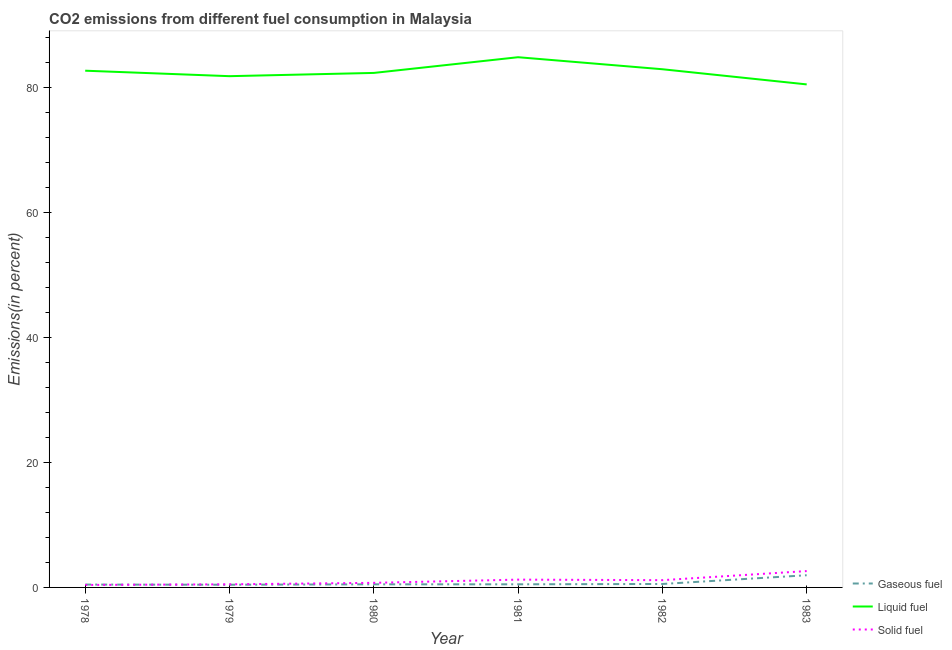How many different coloured lines are there?
Offer a very short reply. 3. Is the number of lines equal to the number of legend labels?
Offer a terse response. Yes. What is the percentage of solid fuel emission in 1982?
Make the answer very short. 1.16. Across all years, what is the maximum percentage of liquid fuel emission?
Your answer should be compact. 84.83. Across all years, what is the minimum percentage of gaseous fuel emission?
Offer a very short reply. 0.43. In which year was the percentage of gaseous fuel emission minimum?
Provide a short and direct response. 1979. What is the total percentage of gaseous fuel emission in the graph?
Your answer should be very brief. 4.39. What is the difference between the percentage of gaseous fuel emission in 1981 and that in 1982?
Keep it short and to the point. -0.05. What is the difference between the percentage of solid fuel emission in 1979 and the percentage of liquid fuel emission in 1978?
Your answer should be very brief. -82.18. What is the average percentage of liquid fuel emission per year?
Make the answer very short. 82.5. In the year 1978, what is the difference between the percentage of liquid fuel emission and percentage of solid fuel emission?
Your answer should be very brief. 82.28. What is the ratio of the percentage of gaseous fuel emission in 1978 to that in 1983?
Provide a short and direct response. 0.23. Is the percentage of liquid fuel emission in 1982 less than that in 1983?
Provide a succinct answer. No. What is the difference between the highest and the second highest percentage of solid fuel emission?
Make the answer very short. 1.37. What is the difference between the highest and the lowest percentage of solid fuel emission?
Give a very brief answer. 2.22. Is it the case that in every year, the sum of the percentage of gaseous fuel emission and percentage of liquid fuel emission is greater than the percentage of solid fuel emission?
Ensure brevity in your answer.  Yes. Is the percentage of liquid fuel emission strictly greater than the percentage of gaseous fuel emission over the years?
Keep it short and to the point. Yes. How many years are there in the graph?
Your response must be concise. 6. Are the values on the major ticks of Y-axis written in scientific E-notation?
Keep it short and to the point. No. Does the graph contain any zero values?
Offer a very short reply. No. How many legend labels are there?
Your answer should be very brief. 3. What is the title of the graph?
Your response must be concise. CO2 emissions from different fuel consumption in Malaysia. What is the label or title of the Y-axis?
Make the answer very short. Emissions(in percent). What is the Emissions(in percent) in Gaseous fuel in 1978?
Offer a terse response. 0.46. What is the Emissions(in percent) of Liquid fuel in 1978?
Your response must be concise. 82.67. What is the Emissions(in percent) of Solid fuel in 1978?
Your answer should be compact. 0.39. What is the Emissions(in percent) in Gaseous fuel in 1979?
Provide a short and direct response. 0.43. What is the Emissions(in percent) in Liquid fuel in 1979?
Offer a very short reply. 81.8. What is the Emissions(in percent) in Solid fuel in 1979?
Your response must be concise. 0.5. What is the Emissions(in percent) in Gaseous fuel in 1980?
Provide a short and direct response. 0.5. What is the Emissions(in percent) of Liquid fuel in 1980?
Give a very brief answer. 82.32. What is the Emissions(in percent) in Solid fuel in 1980?
Provide a succinct answer. 0.73. What is the Emissions(in percent) in Gaseous fuel in 1981?
Keep it short and to the point. 0.5. What is the Emissions(in percent) of Liquid fuel in 1981?
Your answer should be very brief. 84.83. What is the Emissions(in percent) of Solid fuel in 1981?
Ensure brevity in your answer.  1.25. What is the Emissions(in percent) in Gaseous fuel in 1982?
Provide a short and direct response. 0.55. What is the Emissions(in percent) of Liquid fuel in 1982?
Provide a short and direct response. 82.91. What is the Emissions(in percent) in Solid fuel in 1982?
Ensure brevity in your answer.  1.16. What is the Emissions(in percent) in Gaseous fuel in 1983?
Offer a very short reply. 1.95. What is the Emissions(in percent) of Liquid fuel in 1983?
Keep it short and to the point. 80.48. What is the Emissions(in percent) in Solid fuel in 1983?
Provide a succinct answer. 2.62. Across all years, what is the maximum Emissions(in percent) in Gaseous fuel?
Offer a very short reply. 1.95. Across all years, what is the maximum Emissions(in percent) of Liquid fuel?
Provide a succinct answer. 84.83. Across all years, what is the maximum Emissions(in percent) of Solid fuel?
Ensure brevity in your answer.  2.62. Across all years, what is the minimum Emissions(in percent) of Gaseous fuel?
Offer a very short reply. 0.43. Across all years, what is the minimum Emissions(in percent) of Liquid fuel?
Your response must be concise. 80.48. Across all years, what is the minimum Emissions(in percent) of Solid fuel?
Make the answer very short. 0.39. What is the total Emissions(in percent) in Gaseous fuel in the graph?
Ensure brevity in your answer.  4.39. What is the total Emissions(in percent) of Liquid fuel in the graph?
Make the answer very short. 495.01. What is the total Emissions(in percent) in Solid fuel in the graph?
Provide a succinct answer. 6.66. What is the difference between the Emissions(in percent) of Gaseous fuel in 1978 and that in 1979?
Offer a terse response. 0.03. What is the difference between the Emissions(in percent) in Liquid fuel in 1978 and that in 1979?
Offer a very short reply. 0.87. What is the difference between the Emissions(in percent) in Solid fuel in 1978 and that in 1979?
Provide a short and direct response. -0.1. What is the difference between the Emissions(in percent) in Gaseous fuel in 1978 and that in 1980?
Your response must be concise. -0.04. What is the difference between the Emissions(in percent) in Liquid fuel in 1978 and that in 1980?
Offer a terse response. 0.35. What is the difference between the Emissions(in percent) in Solid fuel in 1978 and that in 1980?
Make the answer very short. -0.34. What is the difference between the Emissions(in percent) of Gaseous fuel in 1978 and that in 1981?
Your response must be concise. -0.04. What is the difference between the Emissions(in percent) in Liquid fuel in 1978 and that in 1981?
Provide a short and direct response. -2.16. What is the difference between the Emissions(in percent) in Solid fuel in 1978 and that in 1981?
Your response must be concise. -0.85. What is the difference between the Emissions(in percent) of Gaseous fuel in 1978 and that in 1982?
Make the answer very short. -0.09. What is the difference between the Emissions(in percent) in Liquid fuel in 1978 and that in 1982?
Give a very brief answer. -0.23. What is the difference between the Emissions(in percent) in Solid fuel in 1978 and that in 1982?
Keep it short and to the point. -0.77. What is the difference between the Emissions(in percent) of Gaseous fuel in 1978 and that in 1983?
Make the answer very short. -1.49. What is the difference between the Emissions(in percent) of Liquid fuel in 1978 and that in 1983?
Your answer should be very brief. 2.19. What is the difference between the Emissions(in percent) of Solid fuel in 1978 and that in 1983?
Ensure brevity in your answer.  -2.22. What is the difference between the Emissions(in percent) in Gaseous fuel in 1979 and that in 1980?
Offer a very short reply. -0.07. What is the difference between the Emissions(in percent) of Liquid fuel in 1979 and that in 1980?
Your response must be concise. -0.52. What is the difference between the Emissions(in percent) of Solid fuel in 1979 and that in 1980?
Ensure brevity in your answer.  -0.24. What is the difference between the Emissions(in percent) of Gaseous fuel in 1979 and that in 1981?
Offer a very short reply. -0.07. What is the difference between the Emissions(in percent) in Liquid fuel in 1979 and that in 1981?
Provide a short and direct response. -3.03. What is the difference between the Emissions(in percent) of Solid fuel in 1979 and that in 1981?
Provide a succinct answer. -0.75. What is the difference between the Emissions(in percent) of Gaseous fuel in 1979 and that in 1982?
Keep it short and to the point. -0.12. What is the difference between the Emissions(in percent) in Liquid fuel in 1979 and that in 1982?
Offer a terse response. -1.11. What is the difference between the Emissions(in percent) of Solid fuel in 1979 and that in 1982?
Your response must be concise. -0.67. What is the difference between the Emissions(in percent) in Gaseous fuel in 1979 and that in 1983?
Provide a short and direct response. -1.52. What is the difference between the Emissions(in percent) of Liquid fuel in 1979 and that in 1983?
Give a very brief answer. 1.32. What is the difference between the Emissions(in percent) of Solid fuel in 1979 and that in 1983?
Offer a terse response. -2.12. What is the difference between the Emissions(in percent) in Gaseous fuel in 1980 and that in 1981?
Keep it short and to the point. -0. What is the difference between the Emissions(in percent) of Liquid fuel in 1980 and that in 1981?
Provide a succinct answer. -2.51. What is the difference between the Emissions(in percent) of Solid fuel in 1980 and that in 1981?
Ensure brevity in your answer.  -0.52. What is the difference between the Emissions(in percent) in Gaseous fuel in 1980 and that in 1982?
Your response must be concise. -0.05. What is the difference between the Emissions(in percent) of Liquid fuel in 1980 and that in 1982?
Provide a short and direct response. -0.59. What is the difference between the Emissions(in percent) of Solid fuel in 1980 and that in 1982?
Your response must be concise. -0.43. What is the difference between the Emissions(in percent) in Gaseous fuel in 1980 and that in 1983?
Offer a very short reply. -1.45. What is the difference between the Emissions(in percent) of Liquid fuel in 1980 and that in 1983?
Provide a short and direct response. 1.84. What is the difference between the Emissions(in percent) in Solid fuel in 1980 and that in 1983?
Keep it short and to the point. -1.88. What is the difference between the Emissions(in percent) of Gaseous fuel in 1981 and that in 1982?
Your answer should be compact. -0.05. What is the difference between the Emissions(in percent) in Liquid fuel in 1981 and that in 1982?
Give a very brief answer. 1.92. What is the difference between the Emissions(in percent) of Solid fuel in 1981 and that in 1982?
Make the answer very short. 0.09. What is the difference between the Emissions(in percent) in Gaseous fuel in 1981 and that in 1983?
Provide a short and direct response. -1.45. What is the difference between the Emissions(in percent) of Liquid fuel in 1981 and that in 1983?
Your response must be concise. 4.35. What is the difference between the Emissions(in percent) of Solid fuel in 1981 and that in 1983?
Provide a succinct answer. -1.37. What is the difference between the Emissions(in percent) in Gaseous fuel in 1982 and that in 1983?
Offer a very short reply. -1.4. What is the difference between the Emissions(in percent) in Liquid fuel in 1982 and that in 1983?
Give a very brief answer. 2.42. What is the difference between the Emissions(in percent) of Solid fuel in 1982 and that in 1983?
Provide a short and direct response. -1.45. What is the difference between the Emissions(in percent) in Gaseous fuel in 1978 and the Emissions(in percent) in Liquid fuel in 1979?
Give a very brief answer. -81.34. What is the difference between the Emissions(in percent) in Gaseous fuel in 1978 and the Emissions(in percent) in Solid fuel in 1979?
Your response must be concise. -0.04. What is the difference between the Emissions(in percent) of Liquid fuel in 1978 and the Emissions(in percent) of Solid fuel in 1979?
Make the answer very short. 82.18. What is the difference between the Emissions(in percent) of Gaseous fuel in 1978 and the Emissions(in percent) of Liquid fuel in 1980?
Keep it short and to the point. -81.86. What is the difference between the Emissions(in percent) in Gaseous fuel in 1978 and the Emissions(in percent) in Solid fuel in 1980?
Keep it short and to the point. -0.28. What is the difference between the Emissions(in percent) in Liquid fuel in 1978 and the Emissions(in percent) in Solid fuel in 1980?
Your answer should be very brief. 81.94. What is the difference between the Emissions(in percent) of Gaseous fuel in 1978 and the Emissions(in percent) of Liquid fuel in 1981?
Your response must be concise. -84.37. What is the difference between the Emissions(in percent) of Gaseous fuel in 1978 and the Emissions(in percent) of Solid fuel in 1981?
Your answer should be very brief. -0.79. What is the difference between the Emissions(in percent) in Liquid fuel in 1978 and the Emissions(in percent) in Solid fuel in 1981?
Provide a succinct answer. 81.42. What is the difference between the Emissions(in percent) of Gaseous fuel in 1978 and the Emissions(in percent) of Liquid fuel in 1982?
Your answer should be compact. -82.45. What is the difference between the Emissions(in percent) of Gaseous fuel in 1978 and the Emissions(in percent) of Solid fuel in 1982?
Ensure brevity in your answer.  -0.71. What is the difference between the Emissions(in percent) of Liquid fuel in 1978 and the Emissions(in percent) of Solid fuel in 1982?
Your answer should be very brief. 81.51. What is the difference between the Emissions(in percent) of Gaseous fuel in 1978 and the Emissions(in percent) of Liquid fuel in 1983?
Your answer should be very brief. -80.03. What is the difference between the Emissions(in percent) of Gaseous fuel in 1978 and the Emissions(in percent) of Solid fuel in 1983?
Ensure brevity in your answer.  -2.16. What is the difference between the Emissions(in percent) of Liquid fuel in 1978 and the Emissions(in percent) of Solid fuel in 1983?
Keep it short and to the point. 80.06. What is the difference between the Emissions(in percent) in Gaseous fuel in 1979 and the Emissions(in percent) in Liquid fuel in 1980?
Your answer should be compact. -81.89. What is the difference between the Emissions(in percent) in Gaseous fuel in 1979 and the Emissions(in percent) in Solid fuel in 1980?
Ensure brevity in your answer.  -0.3. What is the difference between the Emissions(in percent) in Liquid fuel in 1979 and the Emissions(in percent) in Solid fuel in 1980?
Provide a short and direct response. 81.07. What is the difference between the Emissions(in percent) of Gaseous fuel in 1979 and the Emissions(in percent) of Liquid fuel in 1981?
Your answer should be compact. -84.4. What is the difference between the Emissions(in percent) in Gaseous fuel in 1979 and the Emissions(in percent) in Solid fuel in 1981?
Keep it short and to the point. -0.82. What is the difference between the Emissions(in percent) of Liquid fuel in 1979 and the Emissions(in percent) of Solid fuel in 1981?
Provide a short and direct response. 80.55. What is the difference between the Emissions(in percent) of Gaseous fuel in 1979 and the Emissions(in percent) of Liquid fuel in 1982?
Ensure brevity in your answer.  -82.48. What is the difference between the Emissions(in percent) in Gaseous fuel in 1979 and the Emissions(in percent) in Solid fuel in 1982?
Your answer should be compact. -0.73. What is the difference between the Emissions(in percent) of Liquid fuel in 1979 and the Emissions(in percent) of Solid fuel in 1982?
Ensure brevity in your answer.  80.64. What is the difference between the Emissions(in percent) of Gaseous fuel in 1979 and the Emissions(in percent) of Liquid fuel in 1983?
Your answer should be very brief. -80.05. What is the difference between the Emissions(in percent) in Gaseous fuel in 1979 and the Emissions(in percent) in Solid fuel in 1983?
Your answer should be compact. -2.19. What is the difference between the Emissions(in percent) in Liquid fuel in 1979 and the Emissions(in percent) in Solid fuel in 1983?
Your response must be concise. 79.18. What is the difference between the Emissions(in percent) of Gaseous fuel in 1980 and the Emissions(in percent) of Liquid fuel in 1981?
Provide a short and direct response. -84.33. What is the difference between the Emissions(in percent) in Gaseous fuel in 1980 and the Emissions(in percent) in Solid fuel in 1981?
Provide a succinct answer. -0.75. What is the difference between the Emissions(in percent) in Liquid fuel in 1980 and the Emissions(in percent) in Solid fuel in 1981?
Your response must be concise. 81.07. What is the difference between the Emissions(in percent) in Gaseous fuel in 1980 and the Emissions(in percent) in Liquid fuel in 1982?
Ensure brevity in your answer.  -82.41. What is the difference between the Emissions(in percent) of Gaseous fuel in 1980 and the Emissions(in percent) of Solid fuel in 1982?
Provide a succinct answer. -0.67. What is the difference between the Emissions(in percent) in Liquid fuel in 1980 and the Emissions(in percent) in Solid fuel in 1982?
Offer a very short reply. 81.15. What is the difference between the Emissions(in percent) in Gaseous fuel in 1980 and the Emissions(in percent) in Liquid fuel in 1983?
Keep it short and to the point. -79.99. What is the difference between the Emissions(in percent) in Gaseous fuel in 1980 and the Emissions(in percent) in Solid fuel in 1983?
Provide a short and direct response. -2.12. What is the difference between the Emissions(in percent) of Liquid fuel in 1980 and the Emissions(in percent) of Solid fuel in 1983?
Give a very brief answer. 79.7. What is the difference between the Emissions(in percent) of Gaseous fuel in 1981 and the Emissions(in percent) of Liquid fuel in 1982?
Offer a very short reply. -82.41. What is the difference between the Emissions(in percent) in Gaseous fuel in 1981 and the Emissions(in percent) in Solid fuel in 1982?
Make the answer very short. -0.66. What is the difference between the Emissions(in percent) in Liquid fuel in 1981 and the Emissions(in percent) in Solid fuel in 1982?
Offer a terse response. 83.67. What is the difference between the Emissions(in percent) of Gaseous fuel in 1981 and the Emissions(in percent) of Liquid fuel in 1983?
Keep it short and to the point. -79.98. What is the difference between the Emissions(in percent) in Gaseous fuel in 1981 and the Emissions(in percent) in Solid fuel in 1983?
Ensure brevity in your answer.  -2.12. What is the difference between the Emissions(in percent) of Liquid fuel in 1981 and the Emissions(in percent) of Solid fuel in 1983?
Keep it short and to the point. 82.22. What is the difference between the Emissions(in percent) in Gaseous fuel in 1982 and the Emissions(in percent) in Liquid fuel in 1983?
Your answer should be very brief. -79.93. What is the difference between the Emissions(in percent) of Gaseous fuel in 1982 and the Emissions(in percent) of Solid fuel in 1983?
Give a very brief answer. -2.07. What is the difference between the Emissions(in percent) in Liquid fuel in 1982 and the Emissions(in percent) in Solid fuel in 1983?
Give a very brief answer. 80.29. What is the average Emissions(in percent) in Gaseous fuel per year?
Ensure brevity in your answer.  0.73. What is the average Emissions(in percent) in Liquid fuel per year?
Offer a very short reply. 82.5. What is the average Emissions(in percent) in Solid fuel per year?
Give a very brief answer. 1.11. In the year 1978, what is the difference between the Emissions(in percent) in Gaseous fuel and Emissions(in percent) in Liquid fuel?
Offer a terse response. -82.22. In the year 1978, what is the difference between the Emissions(in percent) of Gaseous fuel and Emissions(in percent) of Solid fuel?
Offer a very short reply. 0.06. In the year 1978, what is the difference between the Emissions(in percent) of Liquid fuel and Emissions(in percent) of Solid fuel?
Your answer should be very brief. 82.28. In the year 1979, what is the difference between the Emissions(in percent) in Gaseous fuel and Emissions(in percent) in Liquid fuel?
Offer a very short reply. -81.37. In the year 1979, what is the difference between the Emissions(in percent) in Gaseous fuel and Emissions(in percent) in Solid fuel?
Offer a terse response. -0.07. In the year 1979, what is the difference between the Emissions(in percent) in Liquid fuel and Emissions(in percent) in Solid fuel?
Make the answer very short. 81.3. In the year 1980, what is the difference between the Emissions(in percent) in Gaseous fuel and Emissions(in percent) in Liquid fuel?
Your response must be concise. -81.82. In the year 1980, what is the difference between the Emissions(in percent) of Gaseous fuel and Emissions(in percent) of Solid fuel?
Keep it short and to the point. -0.24. In the year 1980, what is the difference between the Emissions(in percent) in Liquid fuel and Emissions(in percent) in Solid fuel?
Your response must be concise. 81.58. In the year 1981, what is the difference between the Emissions(in percent) in Gaseous fuel and Emissions(in percent) in Liquid fuel?
Give a very brief answer. -84.33. In the year 1981, what is the difference between the Emissions(in percent) of Gaseous fuel and Emissions(in percent) of Solid fuel?
Your response must be concise. -0.75. In the year 1981, what is the difference between the Emissions(in percent) of Liquid fuel and Emissions(in percent) of Solid fuel?
Make the answer very short. 83.58. In the year 1982, what is the difference between the Emissions(in percent) of Gaseous fuel and Emissions(in percent) of Liquid fuel?
Your answer should be compact. -82.36. In the year 1982, what is the difference between the Emissions(in percent) of Gaseous fuel and Emissions(in percent) of Solid fuel?
Offer a very short reply. -0.61. In the year 1982, what is the difference between the Emissions(in percent) of Liquid fuel and Emissions(in percent) of Solid fuel?
Your answer should be compact. 81.74. In the year 1983, what is the difference between the Emissions(in percent) of Gaseous fuel and Emissions(in percent) of Liquid fuel?
Ensure brevity in your answer.  -78.53. In the year 1983, what is the difference between the Emissions(in percent) in Gaseous fuel and Emissions(in percent) in Solid fuel?
Your answer should be very brief. -0.67. In the year 1983, what is the difference between the Emissions(in percent) of Liquid fuel and Emissions(in percent) of Solid fuel?
Offer a terse response. 77.87. What is the ratio of the Emissions(in percent) of Gaseous fuel in 1978 to that in 1979?
Provide a short and direct response. 1.06. What is the ratio of the Emissions(in percent) of Liquid fuel in 1978 to that in 1979?
Offer a terse response. 1.01. What is the ratio of the Emissions(in percent) of Solid fuel in 1978 to that in 1979?
Offer a terse response. 0.79. What is the ratio of the Emissions(in percent) in Gaseous fuel in 1978 to that in 1980?
Make the answer very short. 0.92. What is the ratio of the Emissions(in percent) of Solid fuel in 1978 to that in 1980?
Your response must be concise. 0.54. What is the ratio of the Emissions(in percent) of Gaseous fuel in 1978 to that in 1981?
Your response must be concise. 0.92. What is the ratio of the Emissions(in percent) in Liquid fuel in 1978 to that in 1981?
Make the answer very short. 0.97. What is the ratio of the Emissions(in percent) in Solid fuel in 1978 to that in 1981?
Keep it short and to the point. 0.32. What is the ratio of the Emissions(in percent) in Gaseous fuel in 1978 to that in 1982?
Make the answer very short. 0.83. What is the ratio of the Emissions(in percent) in Solid fuel in 1978 to that in 1982?
Your response must be concise. 0.34. What is the ratio of the Emissions(in percent) of Gaseous fuel in 1978 to that in 1983?
Offer a terse response. 0.23. What is the ratio of the Emissions(in percent) of Liquid fuel in 1978 to that in 1983?
Offer a terse response. 1.03. What is the ratio of the Emissions(in percent) in Solid fuel in 1978 to that in 1983?
Offer a very short reply. 0.15. What is the ratio of the Emissions(in percent) in Gaseous fuel in 1979 to that in 1980?
Your answer should be compact. 0.86. What is the ratio of the Emissions(in percent) of Liquid fuel in 1979 to that in 1980?
Provide a succinct answer. 0.99. What is the ratio of the Emissions(in percent) of Solid fuel in 1979 to that in 1980?
Offer a terse response. 0.68. What is the ratio of the Emissions(in percent) in Gaseous fuel in 1979 to that in 1981?
Offer a very short reply. 0.86. What is the ratio of the Emissions(in percent) of Liquid fuel in 1979 to that in 1981?
Ensure brevity in your answer.  0.96. What is the ratio of the Emissions(in percent) in Solid fuel in 1979 to that in 1981?
Your answer should be very brief. 0.4. What is the ratio of the Emissions(in percent) of Gaseous fuel in 1979 to that in 1982?
Your answer should be very brief. 0.78. What is the ratio of the Emissions(in percent) in Liquid fuel in 1979 to that in 1982?
Your answer should be compact. 0.99. What is the ratio of the Emissions(in percent) of Solid fuel in 1979 to that in 1982?
Your response must be concise. 0.43. What is the ratio of the Emissions(in percent) of Gaseous fuel in 1979 to that in 1983?
Offer a very short reply. 0.22. What is the ratio of the Emissions(in percent) of Liquid fuel in 1979 to that in 1983?
Provide a succinct answer. 1.02. What is the ratio of the Emissions(in percent) of Solid fuel in 1979 to that in 1983?
Provide a succinct answer. 0.19. What is the ratio of the Emissions(in percent) of Gaseous fuel in 1980 to that in 1981?
Your response must be concise. 1. What is the ratio of the Emissions(in percent) of Liquid fuel in 1980 to that in 1981?
Make the answer very short. 0.97. What is the ratio of the Emissions(in percent) in Solid fuel in 1980 to that in 1981?
Your answer should be compact. 0.59. What is the ratio of the Emissions(in percent) in Gaseous fuel in 1980 to that in 1982?
Your answer should be compact. 0.9. What is the ratio of the Emissions(in percent) in Solid fuel in 1980 to that in 1982?
Ensure brevity in your answer.  0.63. What is the ratio of the Emissions(in percent) in Gaseous fuel in 1980 to that in 1983?
Ensure brevity in your answer.  0.26. What is the ratio of the Emissions(in percent) of Liquid fuel in 1980 to that in 1983?
Ensure brevity in your answer.  1.02. What is the ratio of the Emissions(in percent) of Solid fuel in 1980 to that in 1983?
Provide a short and direct response. 0.28. What is the ratio of the Emissions(in percent) of Gaseous fuel in 1981 to that in 1982?
Ensure brevity in your answer.  0.91. What is the ratio of the Emissions(in percent) in Liquid fuel in 1981 to that in 1982?
Keep it short and to the point. 1.02. What is the ratio of the Emissions(in percent) of Solid fuel in 1981 to that in 1982?
Keep it short and to the point. 1.07. What is the ratio of the Emissions(in percent) in Gaseous fuel in 1981 to that in 1983?
Make the answer very short. 0.26. What is the ratio of the Emissions(in percent) of Liquid fuel in 1981 to that in 1983?
Make the answer very short. 1.05. What is the ratio of the Emissions(in percent) in Solid fuel in 1981 to that in 1983?
Keep it short and to the point. 0.48. What is the ratio of the Emissions(in percent) in Gaseous fuel in 1982 to that in 1983?
Provide a short and direct response. 0.28. What is the ratio of the Emissions(in percent) of Liquid fuel in 1982 to that in 1983?
Offer a terse response. 1.03. What is the ratio of the Emissions(in percent) of Solid fuel in 1982 to that in 1983?
Offer a very short reply. 0.44. What is the difference between the highest and the second highest Emissions(in percent) in Gaseous fuel?
Ensure brevity in your answer.  1.4. What is the difference between the highest and the second highest Emissions(in percent) of Liquid fuel?
Offer a very short reply. 1.92. What is the difference between the highest and the second highest Emissions(in percent) of Solid fuel?
Provide a short and direct response. 1.37. What is the difference between the highest and the lowest Emissions(in percent) in Gaseous fuel?
Your answer should be very brief. 1.52. What is the difference between the highest and the lowest Emissions(in percent) of Liquid fuel?
Your response must be concise. 4.35. What is the difference between the highest and the lowest Emissions(in percent) in Solid fuel?
Your answer should be compact. 2.22. 